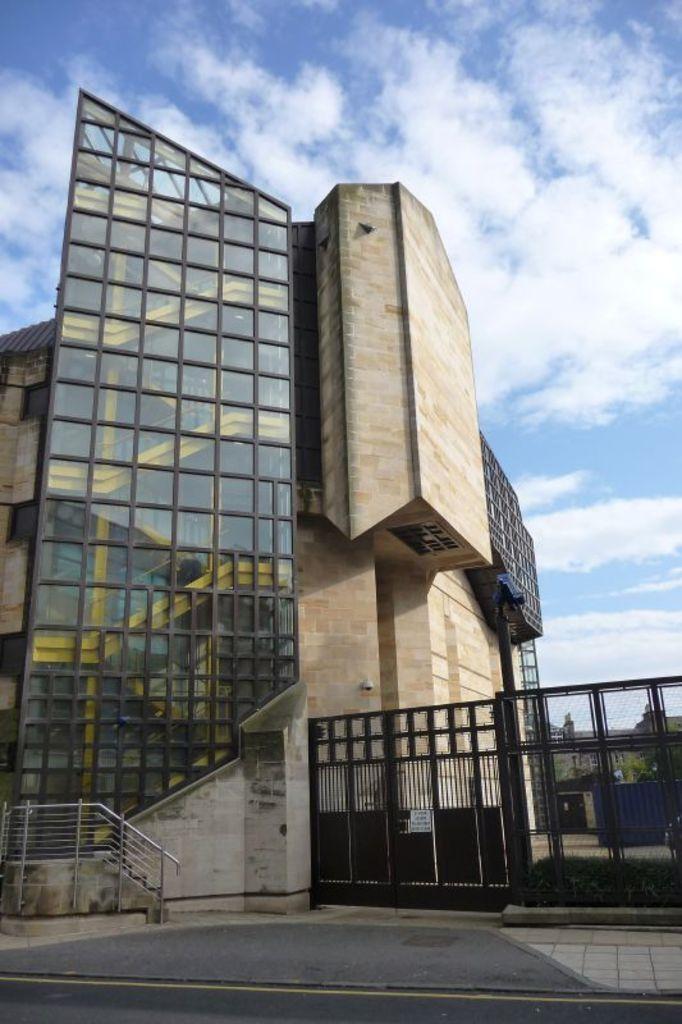Describe this image in one or two sentences. We can see gate,wall,fence,building and plants. In the background we can see tree and sky with clouds. 